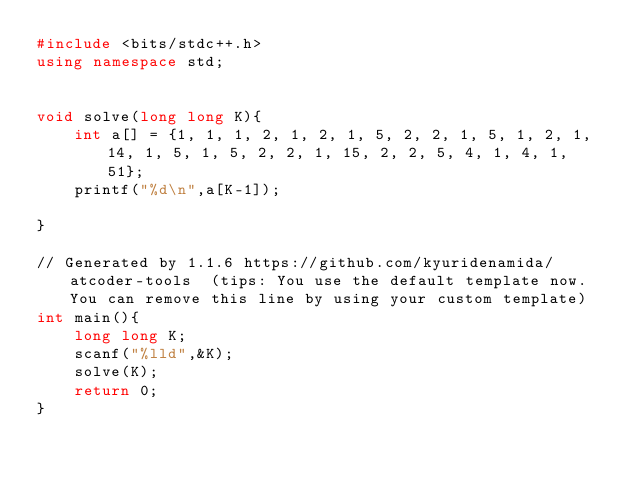Convert code to text. <code><loc_0><loc_0><loc_500><loc_500><_C++_>#include <bits/stdc++.h>
using namespace std;


void solve(long long K){
    int a[] = {1, 1, 1, 2, 1, 2, 1, 5, 2, 2, 1, 5, 1, 2, 1, 14, 1, 5, 1, 5, 2, 2, 1, 15, 2, 2, 5, 4, 1, 4, 1, 51};
    printf("%d\n",a[K-1]);

}

// Generated by 1.1.6 https://github.com/kyuridenamida/atcoder-tools  (tips: You use the default template now. You can remove this line by using your custom template)
int main(){
    long long K;
    scanf("%lld",&K);
    solve(K);
    return 0;
}
</code> 